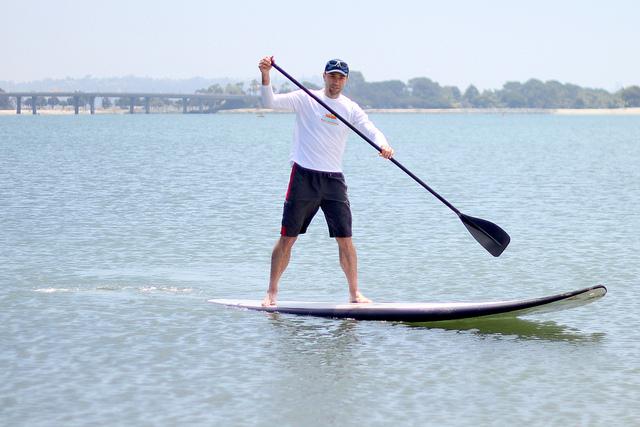Is the person wearing a hat?
Write a very short answer. Yes. Is the water deep?
Write a very short answer. Yes. What is the man standing on?
Concise answer only. Surfboard. 